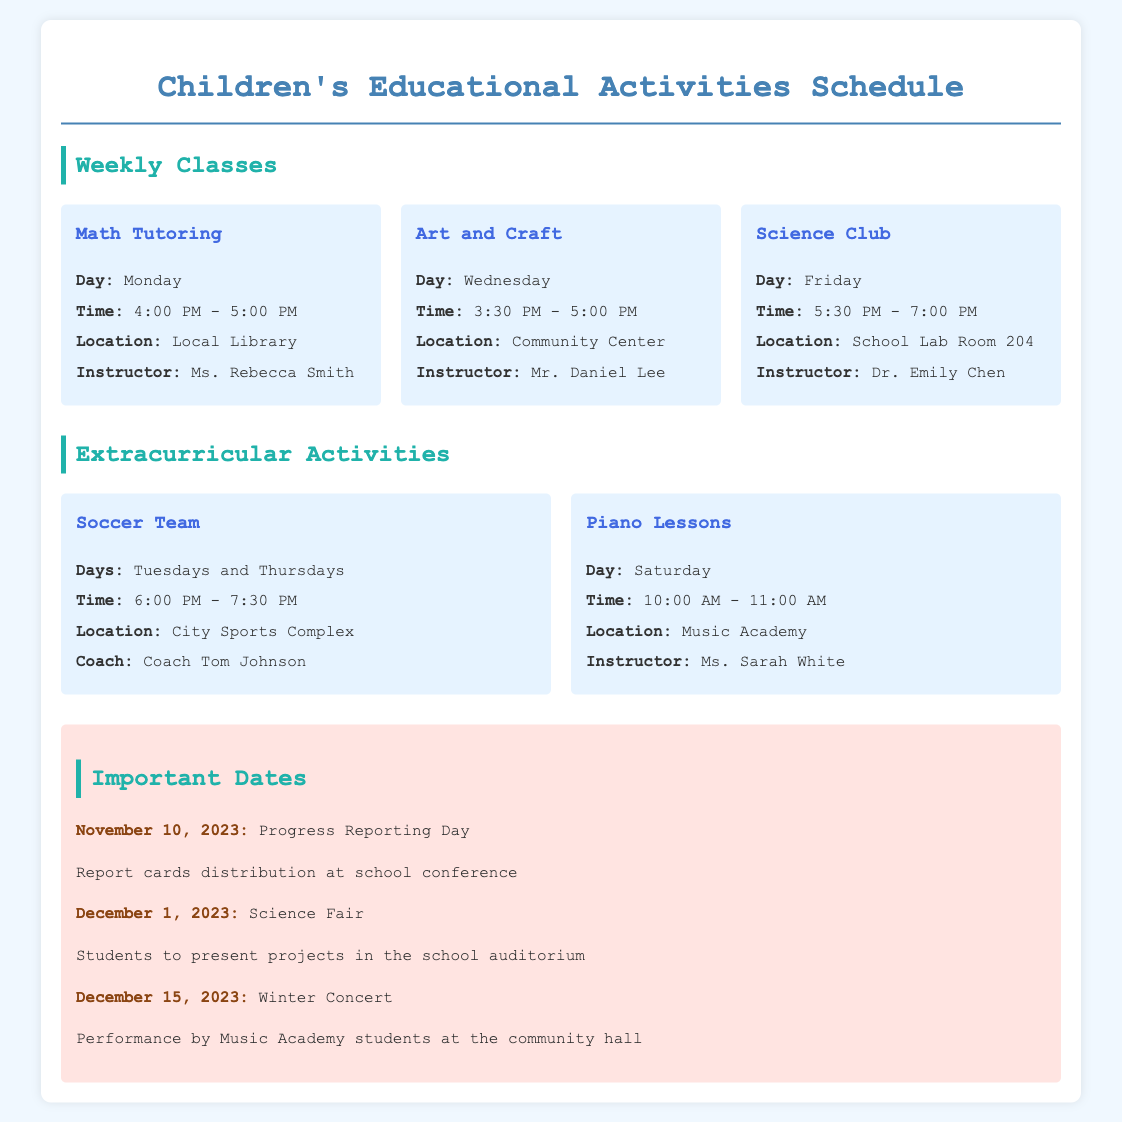What day is Math Tutoring scheduled? The document states that Math Tutoring occurs on Monday.
Answer: Monday Who is the instructor for the Science Club? The document lists Dr. Emily Chen as the instructor for the Science Club.
Answer: Dr. Emily Chen At what time does Art and Craft start? The document indicates that Art and Craft starts at 3:30 PM.
Answer: 3:30 PM What date is Progress Reporting Day? The document specifies that Progress Reporting Day is on November 10, 2023.
Answer: November 10, 2023 How many days a week does the Soccer Team practice? The document mentions that the Soccer Team practices on Tuesdays and Thursdays, which counts as two days.
Answer: Two days Which location is associated with Piano Lessons? According to the document, Piano Lessons take place at Music Academy.
Answer: Music Academy What is the time slot for Science Club meetings? The document states that Science Club meetings occur from 5:30 PM to 7:00 PM.
Answer: 5:30 PM - 7:00 PM What is the main purpose of the important dates section? The "Important Dates" section provides key events and deadlines relevant to the children's schedule.
Answer: Key events and deadlines Which activity is held on December 1, 2023? The document lists the Science Fair as the event on December 1, 2023.
Answer: Science Fair 